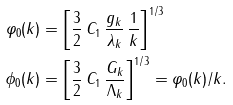<formula> <loc_0><loc_0><loc_500><loc_500>\varphi _ { 0 } ( k ) & = \left [ \frac { 3 } { 2 } \, C _ { 1 } \, \frac { g _ { k } } { \lambda _ { k } } \, \frac { 1 } { k } \right ] ^ { 1 / 3 } \\ \phi _ { 0 } ( k ) & = \left [ \frac { 3 } { 2 } \, C _ { 1 } \, \frac { G _ { k } } { \Lambda _ { k } } \right ] ^ { 1 / 3 } = \varphi _ { 0 } ( k ) / k .</formula> 